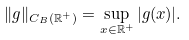<formula> <loc_0><loc_0><loc_500><loc_500>\| g \| _ { C _ { B } ( \mathbb { R } ^ { + } ) } = \sup _ { x \in \mathbb { R } ^ { + } } | g ( x ) | .</formula> 